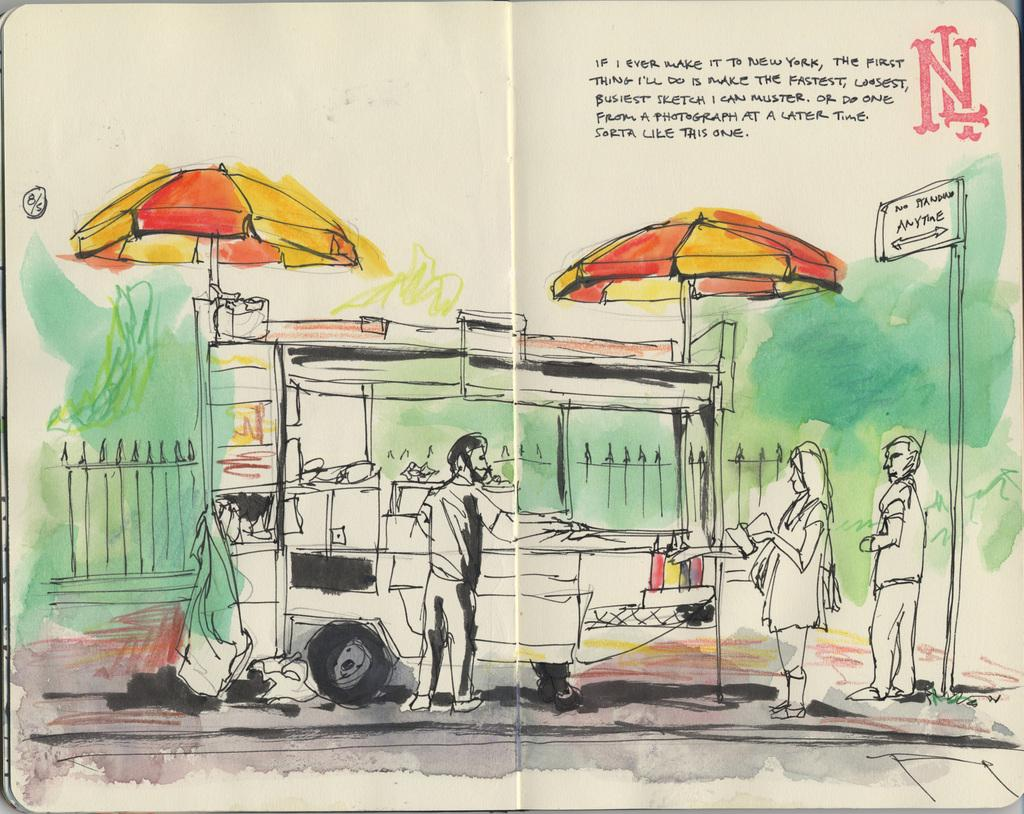What is the main subject of the image? There is a painting in the image. What is depicted in the painting? The painting contains people standing. Are there any objects present in the painting? Yes, there are two umbrellas in the painting. What type of quill is being used by the people in the painting? There is no quill present in the painting; the people are simply standing. How many weeks are depicted in the painting? There is no representation of time or weeks in the painting; it features people standing and two umbrellas. 